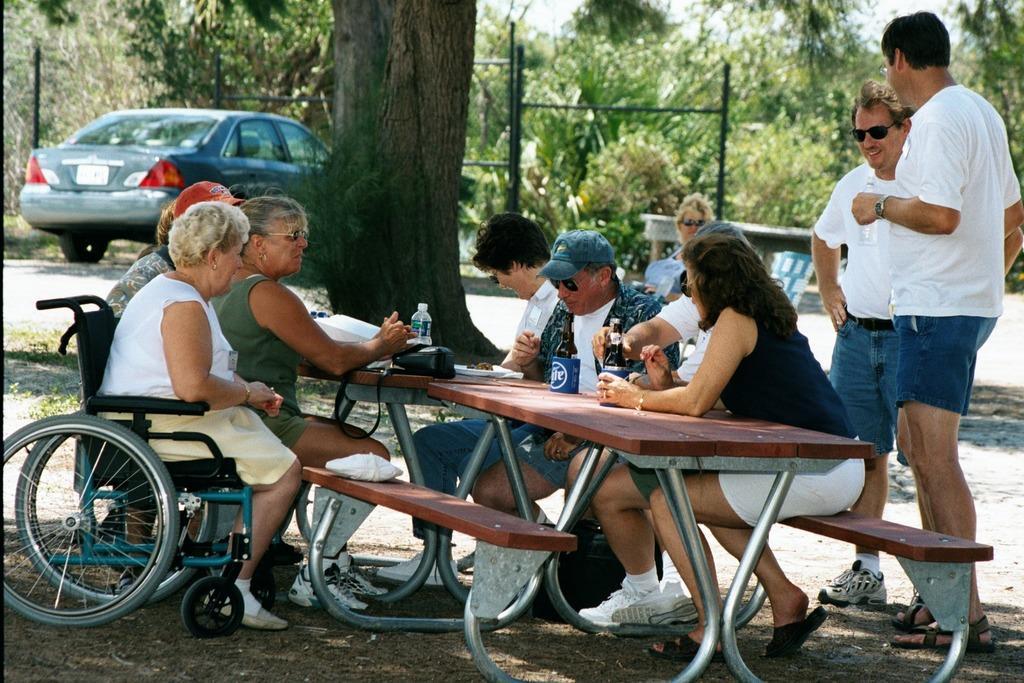Could you give a brief overview of what you see in this image? On the background we can see partial part of a sky and trees and a car. here we can see persons sitting on chairs in front of a table and on the table we can see mug , bottles and a bag. A Woman is sitting on a wheelchair. We can see two men wearing white t shirts standing behind to these persons. 